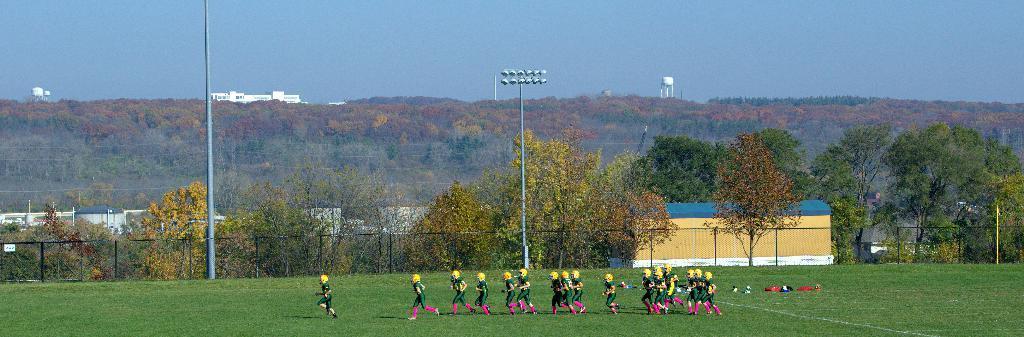In one or two sentences, can you explain what this image depicts? In this image I can see at the bottom a group of people are running in the ground, they wore green color dresses and yellow color helmets. There is an iron net and there are trees in this image. On the right side it looks like a shed in yellow color, at the top it is the sky. 